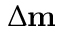Convert formula to latex. <formula><loc_0><loc_0><loc_500><loc_500>\Delta m</formula> 